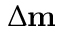Convert formula to latex. <formula><loc_0><loc_0><loc_500><loc_500>\Delta m</formula> 